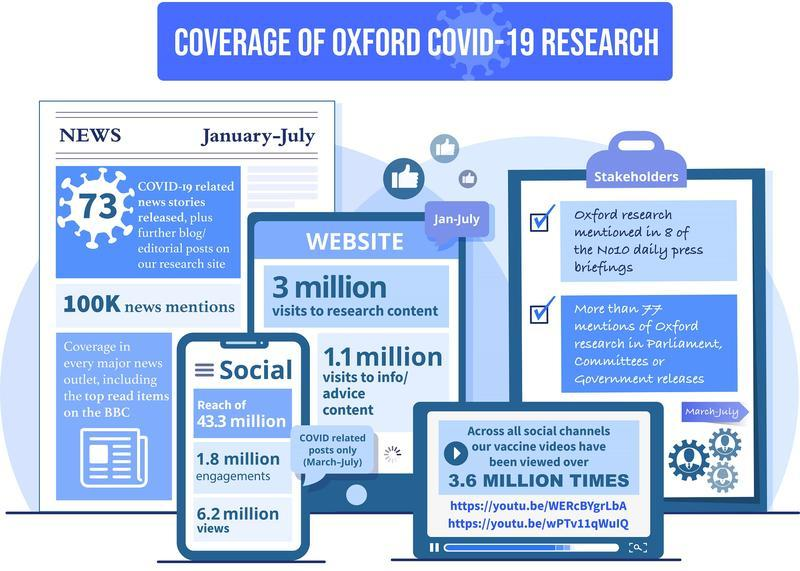List a handful of essential elements in this visual. Oxford COVID-19 research has detected 1.8 million engagements on social media. According to social media data, COVID-19 vaccine videos have been viewed 3.6 million times. According to the website's data, 3 million people searched for information about Oxford's COVID-19 research. 